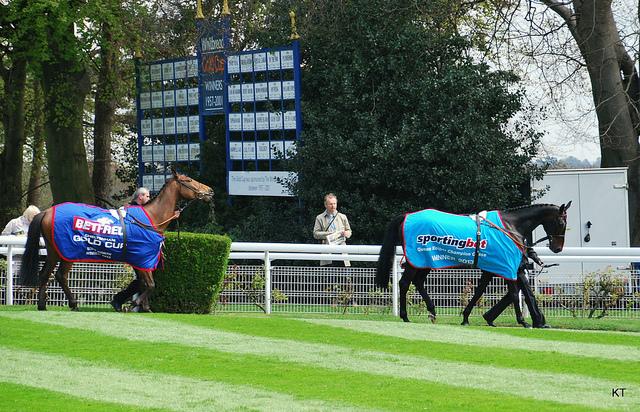What are these horses doing?
Give a very brief answer. Walking. Are there stripes in the grass?
Write a very short answer. Yes. Are these wild horses?
Answer briefly. No. 